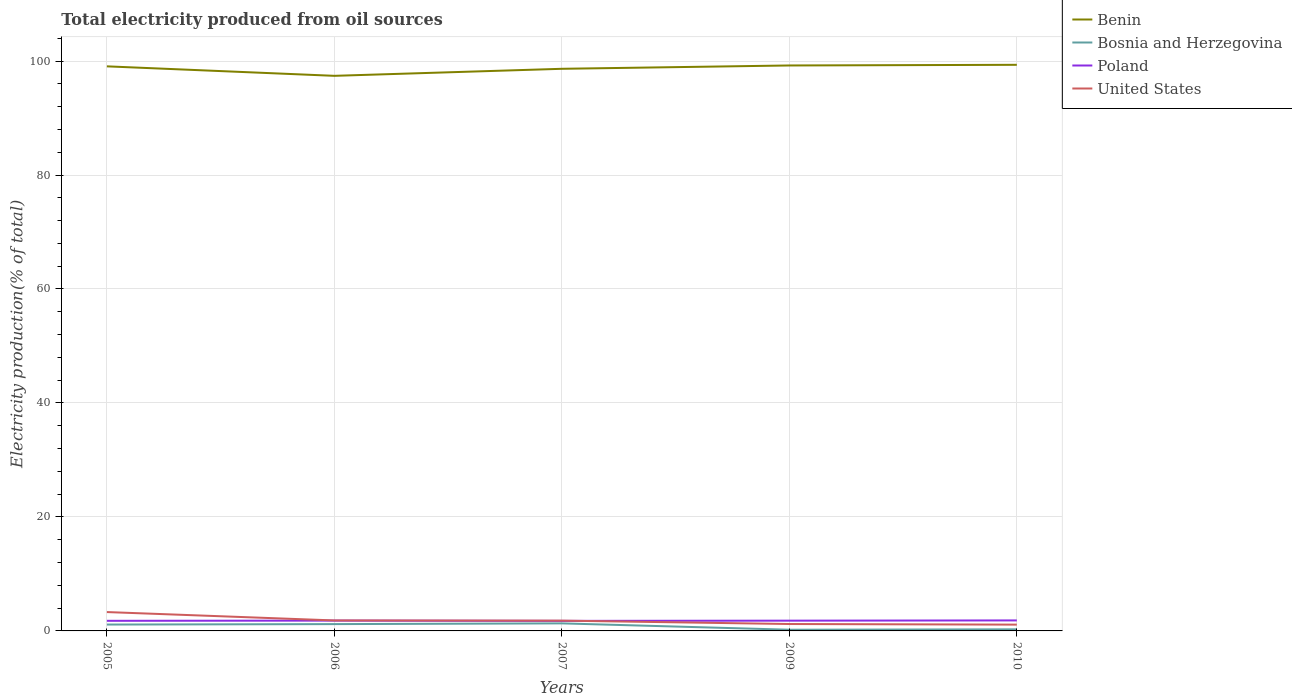Across all years, what is the maximum total electricity produced in United States?
Offer a terse response. 1.1. What is the total total electricity produced in United States in the graph?
Your answer should be compact. 0.11. What is the difference between the highest and the second highest total electricity produced in Bosnia and Herzegovina?
Offer a very short reply. 1.11. What is the difference between the highest and the lowest total electricity produced in Benin?
Give a very brief answer. 3. How many lines are there?
Make the answer very short. 4. What is the difference between two consecutive major ticks on the Y-axis?
Your answer should be compact. 20. Does the graph contain any zero values?
Offer a terse response. No. Does the graph contain grids?
Offer a very short reply. Yes. Where does the legend appear in the graph?
Provide a succinct answer. Top right. How many legend labels are there?
Offer a terse response. 4. How are the legend labels stacked?
Provide a succinct answer. Vertical. What is the title of the graph?
Provide a succinct answer. Total electricity produced from oil sources. Does "Middle income" appear as one of the legend labels in the graph?
Your response must be concise. No. What is the Electricity production(% of total) of Benin in 2005?
Provide a short and direct response. 99.07. What is the Electricity production(% of total) of Bosnia and Herzegovina in 2005?
Your answer should be very brief. 1.12. What is the Electricity production(% of total) of Poland in 2005?
Make the answer very short. 1.77. What is the Electricity production(% of total) in United States in 2005?
Offer a very short reply. 3.31. What is the Electricity production(% of total) in Benin in 2006?
Your answer should be compact. 97.4. What is the Electricity production(% of total) of Bosnia and Herzegovina in 2006?
Offer a terse response. 1.19. What is the Electricity production(% of total) of Poland in 2006?
Make the answer very short. 1.81. What is the Electricity production(% of total) of United States in 2006?
Make the answer very short. 1.84. What is the Electricity production(% of total) in Benin in 2007?
Keep it short and to the point. 98.64. What is the Electricity production(% of total) of Bosnia and Herzegovina in 2007?
Offer a very short reply. 1.32. What is the Electricity production(% of total) of Poland in 2007?
Provide a succinct answer. 1.76. What is the Electricity production(% of total) in United States in 2007?
Your answer should be compact. 1.81. What is the Electricity production(% of total) in Benin in 2009?
Offer a terse response. 99.22. What is the Electricity production(% of total) in Bosnia and Herzegovina in 2009?
Provide a succinct answer. 0.21. What is the Electricity production(% of total) in Poland in 2009?
Offer a terse response. 1.8. What is the Electricity production(% of total) of United States in 2009?
Your response must be concise. 1.21. What is the Electricity production(% of total) in Benin in 2010?
Your answer should be compact. 99.33. What is the Electricity production(% of total) in Bosnia and Herzegovina in 2010?
Keep it short and to the point. 0.28. What is the Electricity production(% of total) in Poland in 2010?
Your answer should be very brief. 1.84. What is the Electricity production(% of total) of United States in 2010?
Provide a short and direct response. 1.1. Across all years, what is the maximum Electricity production(% of total) in Benin?
Provide a short and direct response. 99.33. Across all years, what is the maximum Electricity production(% of total) of Bosnia and Herzegovina?
Give a very brief answer. 1.32. Across all years, what is the maximum Electricity production(% of total) in Poland?
Make the answer very short. 1.84. Across all years, what is the maximum Electricity production(% of total) of United States?
Offer a very short reply. 3.31. Across all years, what is the minimum Electricity production(% of total) of Benin?
Offer a very short reply. 97.4. Across all years, what is the minimum Electricity production(% of total) of Bosnia and Herzegovina?
Your answer should be compact. 0.21. Across all years, what is the minimum Electricity production(% of total) in Poland?
Provide a short and direct response. 1.76. Across all years, what is the minimum Electricity production(% of total) of United States?
Keep it short and to the point. 1.1. What is the total Electricity production(% of total) of Benin in the graph?
Offer a terse response. 493.66. What is the total Electricity production(% of total) in Bosnia and Herzegovina in the graph?
Keep it short and to the point. 4.13. What is the total Electricity production(% of total) in Poland in the graph?
Your answer should be compact. 8.99. What is the total Electricity production(% of total) in United States in the graph?
Offer a very short reply. 9.27. What is the difference between the Electricity production(% of total) of Benin in 2005 and that in 2006?
Your answer should be very brief. 1.66. What is the difference between the Electricity production(% of total) in Bosnia and Herzegovina in 2005 and that in 2006?
Give a very brief answer. -0.08. What is the difference between the Electricity production(% of total) of Poland in 2005 and that in 2006?
Provide a succinct answer. -0.03. What is the difference between the Electricity production(% of total) of United States in 2005 and that in 2006?
Provide a succinct answer. 1.47. What is the difference between the Electricity production(% of total) of Benin in 2005 and that in 2007?
Make the answer very short. 0.43. What is the difference between the Electricity production(% of total) in Bosnia and Herzegovina in 2005 and that in 2007?
Make the answer very short. -0.2. What is the difference between the Electricity production(% of total) in Poland in 2005 and that in 2007?
Your answer should be very brief. 0.01. What is the difference between the Electricity production(% of total) of United States in 2005 and that in 2007?
Your answer should be very brief. 1.5. What is the difference between the Electricity production(% of total) in Benin in 2005 and that in 2009?
Your answer should be very brief. -0.15. What is the difference between the Electricity production(% of total) of Bosnia and Herzegovina in 2005 and that in 2009?
Your response must be concise. 0.91. What is the difference between the Electricity production(% of total) of Poland in 2005 and that in 2009?
Provide a succinct answer. -0.03. What is the difference between the Electricity production(% of total) of United States in 2005 and that in 2009?
Offer a very short reply. 2.1. What is the difference between the Electricity production(% of total) of Benin in 2005 and that in 2010?
Provide a succinct answer. -0.27. What is the difference between the Electricity production(% of total) of Bosnia and Herzegovina in 2005 and that in 2010?
Your response must be concise. 0.84. What is the difference between the Electricity production(% of total) of Poland in 2005 and that in 2010?
Your response must be concise. -0.07. What is the difference between the Electricity production(% of total) of United States in 2005 and that in 2010?
Keep it short and to the point. 2.21. What is the difference between the Electricity production(% of total) in Benin in 2006 and that in 2007?
Give a very brief answer. -1.23. What is the difference between the Electricity production(% of total) in Bosnia and Herzegovina in 2006 and that in 2007?
Give a very brief answer. -0.13. What is the difference between the Electricity production(% of total) of Poland in 2006 and that in 2007?
Give a very brief answer. 0.05. What is the difference between the Electricity production(% of total) in United States in 2006 and that in 2007?
Provide a short and direct response. 0.03. What is the difference between the Electricity production(% of total) of Benin in 2006 and that in 2009?
Make the answer very short. -1.82. What is the difference between the Electricity production(% of total) in Bosnia and Herzegovina in 2006 and that in 2009?
Your answer should be very brief. 0.98. What is the difference between the Electricity production(% of total) in Poland in 2006 and that in 2009?
Give a very brief answer. 0.01. What is the difference between the Electricity production(% of total) in United States in 2006 and that in 2009?
Your response must be concise. 0.63. What is the difference between the Electricity production(% of total) in Benin in 2006 and that in 2010?
Ensure brevity in your answer.  -1.93. What is the difference between the Electricity production(% of total) of Bosnia and Herzegovina in 2006 and that in 2010?
Make the answer very short. 0.91. What is the difference between the Electricity production(% of total) of Poland in 2006 and that in 2010?
Give a very brief answer. -0.03. What is the difference between the Electricity production(% of total) in United States in 2006 and that in 2010?
Your response must be concise. 0.73. What is the difference between the Electricity production(% of total) in Benin in 2007 and that in 2009?
Provide a succinct answer. -0.58. What is the difference between the Electricity production(% of total) of Bosnia and Herzegovina in 2007 and that in 2009?
Your answer should be compact. 1.11. What is the difference between the Electricity production(% of total) of Poland in 2007 and that in 2009?
Offer a terse response. -0.04. What is the difference between the Electricity production(% of total) in United States in 2007 and that in 2009?
Make the answer very short. 0.6. What is the difference between the Electricity production(% of total) of Benin in 2007 and that in 2010?
Your response must be concise. -0.7. What is the difference between the Electricity production(% of total) in Bosnia and Herzegovina in 2007 and that in 2010?
Keep it short and to the point. 1.04. What is the difference between the Electricity production(% of total) of Poland in 2007 and that in 2010?
Provide a short and direct response. -0.08. What is the difference between the Electricity production(% of total) of United States in 2007 and that in 2010?
Make the answer very short. 0.7. What is the difference between the Electricity production(% of total) in Benin in 2009 and that in 2010?
Give a very brief answer. -0.11. What is the difference between the Electricity production(% of total) in Bosnia and Herzegovina in 2009 and that in 2010?
Give a very brief answer. -0.07. What is the difference between the Electricity production(% of total) in Poland in 2009 and that in 2010?
Offer a terse response. -0.04. What is the difference between the Electricity production(% of total) of United States in 2009 and that in 2010?
Keep it short and to the point. 0.11. What is the difference between the Electricity production(% of total) in Benin in 2005 and the Electricity production(% of total) in Bosnia and Herzegovina in 2006?
Provide a short and direct response. 97.87. What is the difference between the Electricity production(% of total) in Benin in 2005 and the Electricity production(% of total) in Poland in 2006?
Offer a terse response. 97.26. What is the difference between the Electricity production(% of total) in Benin in 2005 and the Electricity production(% of total) in United States in 2006?
Offer a very short reply. 97.23. What is the difference between the Electricity production(% of total) in Bosnia and Herzegovina in 2005 and the Electricity production(% of total) in Poland in 2006?
Keep it short and to the point. -0.69. What is the difference between the Electricity production(% of total) of Bosnia and Herzegovina in 2005 and the Electricity production(% of total) of United States in 2006?
Provide a short and direct response. -0.72. What is the difference between the Electricity production(% of total) of Poland in 2005 and the Electricity production(% of total) of United States in 2006?
Give a very brief answer. -0.06. What is the difference between the Electricity production(% of total) in Benin in 2005 and the Electricity production(% of total) in Bosnia and Herzegovina in 2007?
Provide a short and direct response. 97.74. What is the difference between the Electricity production(% of total) of Benin in 2005 and the Electricity production(% of total) of Poland in 2007?
Ensure brevity in your answer.  97.31. What is the difference between the Electricity production(% of total) of Benin in 2005 and the Electricity production(% of total) of United States in 2007?
Keep it short and to the point. 97.26. What is the difference between the Electricity production(% of total) of Bosnia and Herzegovina in 2005 and the Electricity production(% of total) of Poland in 2007?
Your answer should be compact. -0.64. What is the difference between the Electricity production(% of total) of Bosnia and Herzegovina in 2005 and the Electricity production(% of total) of United States in 2007?
Your answer should be very brief. -0.69. What is the difference between the Electricity production(% of total) of Poland in 2005 and the Electricity production(% of total) of United States in 2007?
Provide a succinct answer. -0.03. What is the difference between the Electricity production(% of total) of Benin in 2005 and the Electricity production(% of total) of Bosnia and Herzegovina in 2009?
Your answer should be very brief. 98.85. What is the difference between the Electricity production(% of total) in Benin in 2005 and the Electricity production(% of total) in Poland in 2009?
Provide a short and direct response. 97.26. What is the difference between the Electricity production(% of total) of Benin in 2005 and the Electricity production(% of total) of United States in 2009?
Keep it short and to the point. 97.85. What is the difference between the Electricity production(% of total) of Bosnia and Herzegovina in 2005 and the Electricity production(% of total) of Poland in 2009?
Make the answer very short. -0.68. What is the difference between the Electricity production(% of total) in Bosnia and Herzegovina in 2005 and the Electricity production(% of total) in United States in 2009?
Offer a terse response. -0.09. What is the difference between the Electricity production(% of total) in Poland in 2005 and the Electricity production(% of total) in United States in 2009?
Offer a very short reply. 0.56. What is the difference between the Electricity production(% of total) in Benin in 2005 and the Electricity production(% of total) in Bosnia and Herzegovina in 2010?
Give a very brief answer. 98.79. What is the difference between the Electricity production(% of total) in Benin in 2005 and the Electricity production(% of total) in Poland in 2010?
Provide a short and direct response. 97.22. What is the difference between the Electricity production(% of total) in Benin in 2005 and the Electricity production(% of total) in United States in 2010?
Provide a succinct answer. 97.96. What is the difference between the Electricity production(% of total) in Bosnia and Herzegovina in 2005 and the Electricity production(% of total) in Poland in 2010?
Offer a very short reply. -0.72. What is the difference between the Electricity production(% of total) in Bosnia and Herzegovina in 2005 and the Electricity production(% of total) in United States in 2010?
Make the answer very short. 0.01. What is the difference between the Electricity production(% of total) in Poland in 2005 and the Electricity production(% of total) in United States in 2010?
Your response must be concise. 0.67. What is the difference between the Electricity production(% of total) in Benin in 2006 and the Electricity production(% of total) in Bosnia and Herzegovina in 2007?
Ensure brevity in your answer.  96.08. What is the difference between the Electricity production(% of total) of Benin in 2006 and the Electricity production(% of total) of Poland in 2007?
Your answer should be compact. 95.64. What is the difference between the Electricity production(% of total) in Benin in 2006 and the Electricity production(% of total) in United States in 2007?
Your response must be concise. 95.6. What is the difference between the Electricity production(% of total) of Bosnia and Herzegovina in 2006 and the Electricity production(% of total) of Poland in 2007?
Provide a short and direct response. -0.57. What is the difference between the Electricity production(% of total) of Bosnia and Herzegovina in 2006 and the Electricity production(% of total) of United States in 2007?
Keep it short and to the point. -0.61. What is the difference between the Electricity production(% of total) of Poland in 2006 and the Electricity production(% of total) of United States in 2007?
Offer a terse response. 0. What is the difference between the Electricity production(% of total) in Benin in 2006 and the Electricity production(% of total) in Bosnia and Herzegovina in 2009?
Keep it short and to the point. 97.19. What is the difference between the Electricity production(% of total) of Benin in 2006 and the Electricity production(% of total) of Poland in 2009?
Give a very brief answer. 95.6. What is the difference between the Electricity production(% of total) of Benin in 2006 and the Electricity production(% of total) of United States in 2009?
Provide a succinct answer. 96.19. What is the difference between the Electricity production(% of total) of Bosnia and Herzegovina in 2006 and the Electricity production(% of total) of Poland in 2009?
Your answer should be compact. -0.61. What is the difference between the Electricity production(% of total) in Bosnia and Herzegovina in 2006 and the Electricity production(% of total) in United States in 2009?
Give a very brief answer. -0.02. What is the difference between the Electricity production(% of total) of Poland in 2006 and the Electricity production(% of total) of United States in 2009?
Offer a very short reply. 0.6. What is the difference between the Electricity production(% of total) of Benin in 2006 and the Electricity production(% of total) of Bosnia and Herzegovina in 2010?
Ensure brevity in your answer.  97.12. What is the difference between the Electricity production(% of total) of Benin in 2006 and the Electricity production(% of total) of Poland in 2010?
Provide a short and direct response. 95.56. What is the difference between the Electricity production(% of total) in Benin in 2006 and the Electricity production(% of total) in United States in 2010?
Give a very brief answer. 96.3. What is the difference between the Electricity production(% of total) of Bosnia and Herzegovina in 2006 and the Electricity production(% of total) of Poland in 2010?
Your answer should be very brief. -0.65. What is the difference between the Electricity production(% of total) of Bosnia and Herzegovina in 2006 and the Electricity production(% of total) of United States in 2010?
Keep it short and to the point. 0.09. What is the difference between the Electricity production(% of total) in Poland in 2006 and the Electricity production(% of total) in United States in 2010?
Ensure brevity in your answer.  0.71. What is the difference between the Electricity production(% of total) in Benin in 2007 and the Electricity production(% of total) in Bosnia and Herzegovina in 2009?
Your response must be concise. 98.43. What is the difference between the Electricity production(% of total) of Benin in 2007 and the Electricity production(% of total) of Poland in 2009?
Offer a very short reply. 96.83. What is the difference between the Electricity production(% of total) of Benin in 2007 and the Electricity production(% of total) of United States in 2009?
Offer a terse response. 97.43. What is the difference between the Electricity production(% of total) of Bosnia and Herzegovina in 2007 and the Electricity production(% of total) of Poland in 2009?
Your answer should be very brief. -0.48. What is the difference between the Electricity production(% of total) of Bosnia and Herzegovina in 2007 and the Electricity production(% of total) of United States in 2009?
Your response must be concise. 0.11. What is the difference between the Electricity production(% of total) in Poland in 2007 and the Electricity production(% of total) in United States in 2009?
Provide a short and direct response. 0.55. What is the difference between the Electricity production(% of total) of Benin in 2007 and the Electricity production(% of total) of Bosnia and Herzegovina in 2010?
Ensure brevity in your answer.  98.36. What is the difference between the Electricity production(% of total) of Benin in 2007 and the Electricity production(% of total) of Poland in 2010?
Provide a short and direct response. 96.8. What is the difference between the Electricity production(% of total) in Benin in 2007 and the Electricity production(% of total) in United States in 2010?
Your response must be concise. 97.53. What is the difference between the Electricity production(% of total) in Bosnia and Herzegovina in 2007 and the Electricity production(% of total) in Poland in 2010?
Give a very brief answer. -0.52. What is the difference between the Electricity production(% of total) of Bosnia and Herzegovina in 2007 and the Electricity production(% of total) of United States in 2010?
Keep it short and to the point. 0.22. What is the difference between the Electricity production(% of total) of Poland in 2007 and the Electricity production(% of total) of United States in 2010?
Make the answer very short. 0.66. What is the difference between the Electricity production(% of total) in Benin in 2009 and the Electricity production(% of total) in Bosnia and Herzegovina in 2010?
Offer a very short reply. 98.94. What is the difference between the Electricity production(% of total) of Benin in 2009 and the Electricity production(% of total) of Poland in 2010?
Offer a terse response. 97.38. What is the difference between the Electricity production(% of total) of Benin in 2009 and the Electricity production(% of total) of United States in 2010?
Provide a short and direct response. 98.11. What is the difference between the Electricity production(% of total) of Bosnia and Herzegovina in 2009 and the Electricity production(% of total) of Poland in 2010?
Give a very brief answer. -1.63. What is the difference between the Electricity production(% of total) of Bosnia and Herzegovina in 2009 and the Electricity production(% of total) of United States in 2010?
Offer a very short reply. -0.89. What is the difference between the Electricity production(% of total) of Poland in 2009 and the Electricity production(% of total) of United States in 2010?
Provide a short and direct response. 0.7. What is the average Electricity production(% of total) of Benin per year?
Give a very brief answer. 98.73. What is the average Electricity production(% of total) in Bosnia and Herzegovina per year?
Offer a very short reply. 0.83. What is the average Electricity production(% of total) in Poland per year?
Your response must be concise. 1.8. What is the average Electricity production(% of total) in United States per year?
Provide a succinct answer. 1.85. In the year 2005, what is the difference between the Electricity production(% of total) in Benin and Electricity production(% of total) in Bosnia and Herzegovina?
Your answer should be compact. 97.95. In the year 2005, what is the difference between the Electricity production(% of total) of Benin and Electricity production(% of total) of Poland?
Keep it short and to the point. 97.29. In the year 2005, what is the difference between the Electricity production(% of total) in Benin and Electricity production(% of total) in United States?
Your answer should be compact. 95.76. In the year 2005, what is the difference between the Electricity production(% of total) of Bosnia and Herzegovina and Electricity production(% of total) of Poland?
Provide a short and direct response. -0.66. In the year 2005, what is the difference between the Electricity production(% of total) in Bosnia and Herzegovina and Electricity production(% of total) in United States?
Ensure brevity in your answer.  -2.19. In the year 2005, what is the difference between the Electricity production(% of total) of Poland and Electricity production(% of total) of United States?
Provide a succinct answer. -1.54. In the year 2006, what is the difference between the Electricity production(% of total) in Benin and Electricity production(% of total) in Bosnia and Herzegovina?
Offer a terse response. 96.21. In the year 2006, what is the difference between the Electricity production(% of total) in Benin and Electricity production(% of total) in Poland?
Keep it short and to the point. 95.59. In the year 2006, what is the difference between the Electricity production(% of total) in Benin and Electricity production(% of total) in United States?
Make the answer very short. 95.56. In the year 2006, what is the difference between the Electricity production(% of total) in Bosnia and Herzegovina and Electricity production(% of total) in Poland?
Provide a short and direct response. -0.61. In the year 2006, what is the difference between the Electricity production(% of total) in Bosnia and Herzegovina and Electricity production(% of total) in United States?
Your answer should be very brief. -0.64. In the year 2006, what is the difference between the Electricity production(% of total) of Poland and Electricity production(% of total) of United States?
Provide a succinct answer. -0.03. In the year 2007, what is the difference between the Electricity production(% of total) of Benin and Electricity production(% of total) of Bosnia and Herzegovina?
Offer a terse response. 97.31. In the year 2007, what is the difference between the Electricity production(% of total) in Benin and Electricity production(% of total) in Poland?
Provide a succinct answer. 96.88. In the year 2007, what is the difference between the Electricity production(% of total) in Benin and Electricity production(% of total) in United States?
Offer a very short reply. 96.83. In the year 2007, what is the difference between the Electricity production(% of total) in Bosnia and Herzegovina and Electricity production(% of total) in Poland?
Provide a succinct answer. -0.44. In the year 2007, what is the difference between the Electricity production(% of total) in Bosnia and Herzegovina and Electricity production(% of total) in United States?
Provide a short and direct response. -0.48. In the year 2007, what is the difference between the Electricity production(% of total) of Poland and Electricity production(% of total) of United States?
Your response must be concise. -0.05. In the year 2009, what is the difference between the Electricity production(% of total) of Benin and Electricity production(% of total) of Bosnia and Herzegovina?
Keep it short and to the point. 99.01. In the year 2009, what is the difference between the Electricity production(% of total) of Benin and Electricity production(% of total) of Poland?
Your answer should be compact. 97.42. In the year 2009, what is the difference between the Electricity production(% of total) in Benin and Electricity production(% of total) in United States?
Offer a terse response. 98.01. In the year 2009, what is the difference between the Electricity production(% of total) of Bosnia and Herzegovina and Electricity production(% of total) of Poland?
Provide a succinct answer. -1.59. In the year 2009, what is the difference between the Electricity production(% of total) of Bosnia and Herzegovina and Electricity production(% of total) of United States?
Make the answer very short. -1. In the year 2009, what is the difference between the Electricity production(% of total) of Poland and Electricity production(% of total) of United States?
Ensure brevity in your answer.  0.59. In the year 2010, what is the difference between the Electricity production(% of total) of Benin and Electricity production(% of total) of Bosnia and Herzegovina?
Your answer should be compact. 99.05. In the year 2010, what is the difference between the Electricity production(% of total) of Benin and Electricity production(% of total) of Poland?
Make the answer very short. 97.49. In the year 2010, what is the difference between the Electricity production(% of total) in Benin and Electricity production(% of total) in United States?
Make the answer very short. 98.23. In the year 2010, what is the difference between the Electricity production(% of total) of Bosnia and Herzegovina and Electricity production(% of total) of Poland?
Keep it short and to the point. -1.56. In the year 2010, what is the difference between the Electricity production(% of total) in Bosnia and Herzegovina and Electricity production(% of total) in United States?
Your answer should be compact. -0.82. In the year 2010, what is the difference between the Electricity production(% of total) of Poland and Electricity production(% of total) of United States?
Make the answer very short. 0.74. What is the ratio of the Electricity production(% of total) in Benin in 2005 to that in 2006?
Your answer should be very brief. 1.02. What is the ratio of the Electricity production(% of total) in Bosnia and Herzegovina in 2005 to that in 2006?
Keep it short and to the point. 0.94. What is the ratio of the Electricity production(% of total) of Poland in 2005 to that in 2006?
Offer a very short reply. 0.98. What is the ratio of the Electricity production(% of total) of United States in 2005 to that in 2006?
Ensure brevity in your answer.  1.8. What is the ratio of the Electricity production(% of total) in Benin in 2005 to that in 2007?
Your answer should be very brief. 1. What is the ratio of the Electricity production(% of total) in Bosnia and Herzegovina in 2005 to that in 2007?
Ensure brevity in your answer.  0.85. What is the ratio of the Electricity production(% of total) in Poland in 2005 to that in 2007?
Give a very brief answer. 1.01. What is the ratio of the Electricity production(% of total) in United States in 2005 to that in 2007?
Ensure brevity in your answer.  1.83. What is the ratio of the Electricity production(% of total) of Bosnia and Herzegovina in 2005 to that in 2009?
Make the answer very short. 5.31. What is the ratio of the Electricity production(% of total) in Poland in 2005 to that in 2009?
Provide a succinct answer. 0.98. What is the ratio of the Electricity production(% of total) in United States in 2005 to that in 2009?
Your answer should be very brief. 2.73. What is the ratio of the Electricity production(% of total) in Benin in 2005 to that in 2010?
Offer a very short reply. 1. What is the ratio of the Electricity production(% of total) of Bosnia and Herzegovina in 2005 to that in 2010?
Your answer should be compact. 3.99. What is the ratio of the Electricity production(% of total) in Poland in 2005 to that in 2010?
Your answer should be very brief. 0.96. What is the ratio of the Electricity production(% of total) in United States in 2005 to that in 2010?
Your answer should be very brief. 3. What is the ratio of the Electricity production(% of total) of Benin in 2006 to that in 2007?
Ensure brevity in your answer.  0.99. What is the ratio of the Electricity production(% of total) of Bosnia and Herzegovina in 2006 to that in 2007?
Keep it short and to the point. 0.9. What is the ratio of the Electricity production(% of total) of Poland in 2006 to that in 2007?
Ensure brevity in your answer.  1.03. What is the ratio of the Electricity production(% of total) in United States in 2006 to that in 2007?
Offer a very short reply. 1.02. What is the ratio of the Electricity production(% of total) in Benin in 2006 to that in 2009?
Your answer should be compact. 0.98. What is the ratio of the Electricity production(% of total) of Bosnia and Herzegovina in 2006 to that in 2009?
Make the answer very short. 5.67. What is the ratio of the Electricity production(% of total) in United States in 2006 to that in 2009?
Provide a short and direct response. 1.52. What is the ratio of the Electricity production(% of total) of Benin in 2006 to that in 2010?
Your answer should be very brief. 0.98. What is the ratio of the Electricity production(% of total) of Bosnia and Herzegovina in 2006 to that in 2010?
Keep it short and to the point. 4.26. What is the ratio of the Electricity production(% of total) in Poland in 2006 to that in 2010?
Your answer should be compact. 0.98. What is the ratio of the Electricity production(% of total) in United States in 2006 to that in 2010?
Your answer should be very brief. 1.67. What is the ratio of the Electricity production(% of total) in Benin in 2007 to that in 2009?
Provide a succinct answer. 0.99. What is the ratio of the Electricity production(% of total) of Bosnia and Herzegovina in 2007 to that in 2009?
Offer a terse response. 6.29. What is the ratio of the Electricity production(% of total) of Poland in 2007 to that in 2009?
Offer a very short reply. 0.98. What is the ratio of the Electricity production(% of total) of United States in 2007 to that in 2009?
Your answer should be very brief. 1.49. What is the ratio of the Electricity production(% of total) of Benin in 2007 to that in 2010?
Offer a very short reply. 0.99. What is the ratio of the Electricity production(% of total) in Bosnia and Herzegovina in 2007 to that in 2010?
Offer a terse response. 4.72. What is the ratio of the Electricity production(% of total) in Poland in 2007 to that in 2010?
Keep it short and to the point. 0.96. What is the ratio of the Electricity production(% of total) in United States in 2007 to that in 2010?
Make the answer very short. 1.64. What is the ratio of the Electricity production(% of total) in Bosnia and Herzegovina in 2009 to that in 2010?
Ensure brevity in your answer.  0.75. What is the ratio of the Electricity production(% of total) of Poland in 2009 to that in 2010?
Your answer should be compact. 0.98. What is the ratio of the Electricity production(% of total) in United States in 2009 to that in 2010?
Your answer should be very brief. 1.1. What is the difference between the highest and the second highest Electricity production(% of total) of Benin?
Keep it short and to the point. 0.11. What is the difference between the highest and the second highest Electricity production(% of total) of Bosnia and Herzegovina?
Provide a succinct answer. 0.13. What is the difference between the highest and the second highest Electricity production(% of total) of Poland?
Offer a very short reply. 0.03. What is the difference between the highest and the second highest Electricity production(% of total) of United States?
Keep it short and to the point. 1.47. What is the difference between the highest and the lowest Electricity production(% of total) of Benin?
Ensure brevity in your answer.  1.93. What is the difference between the highest and the lowest Electricity production(% of total) in Bosnia and Herzegovina?
Offer a terse response. 1.11. What is the difference between the highest and the lowest Electricity production(% of total) of Poland?
Provide a short and direct response. 0.08. What is the difference between the highest and the lowest Electricity production(% of total) of United States?
Ensure brevity in your answer.  2.21. 